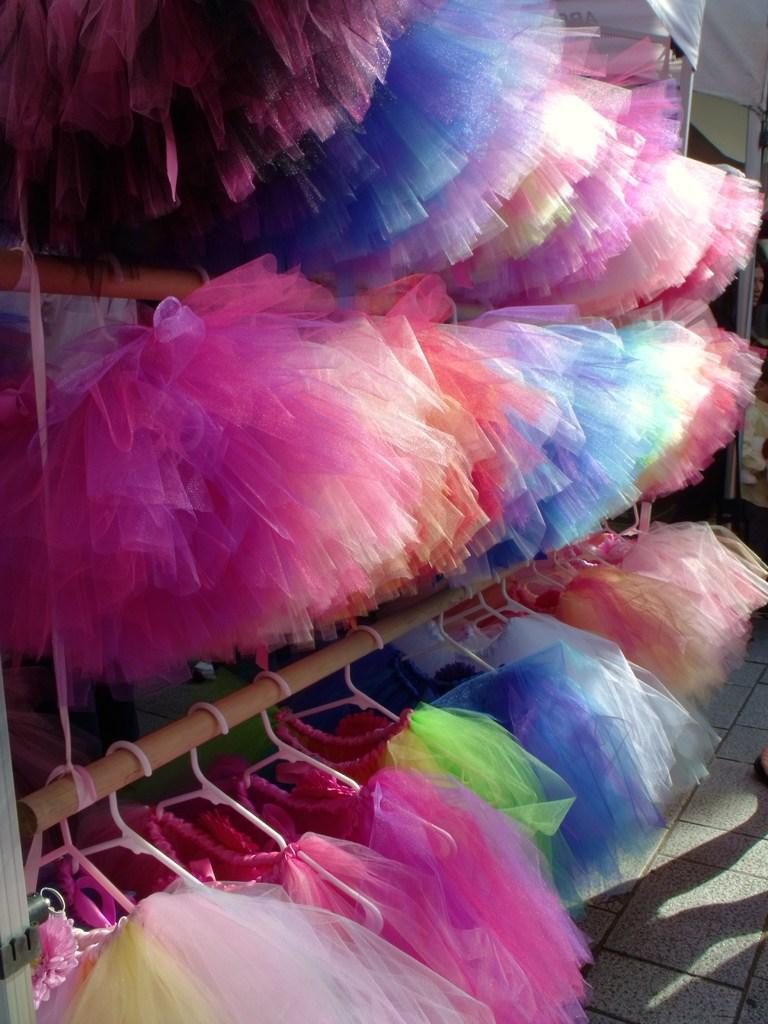What type of objects are featured in the image? There are colorful rocks in the image. How are the colorful rocks displayed in the image? The colorful rocks are hanging from hangers. What type of vehicles can be seen driving through the colorful rocks in the image? There are no vehicles present in the image; it features colorful rocks hanging from hangers. What type of drink is being served in the image alongside the colorful rocks? There is no drink present in the image; it only features colorful rocks hanging from hangers. 